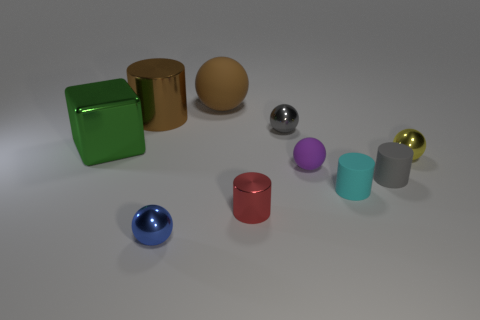Subtract all brown rubber balls. How many balls are left? 4 Subtract all yellow spheres. How many spheres are left? 4 Subtract all green spheres. Subtract all gray blocks. How many spheres are left? 5 Subtract all cubes. How many objects are left? 9 Add 4 small gray shiny balls. How many small gray shiny balls exist? 5 Subtract 0 cyan balls. How many objects are left? 10 Subtract all brown metallic spheres. Subtract all red objects. How many objects are left? 9 Add 5 large green metal objects. How many large green metal objects are left? 6 